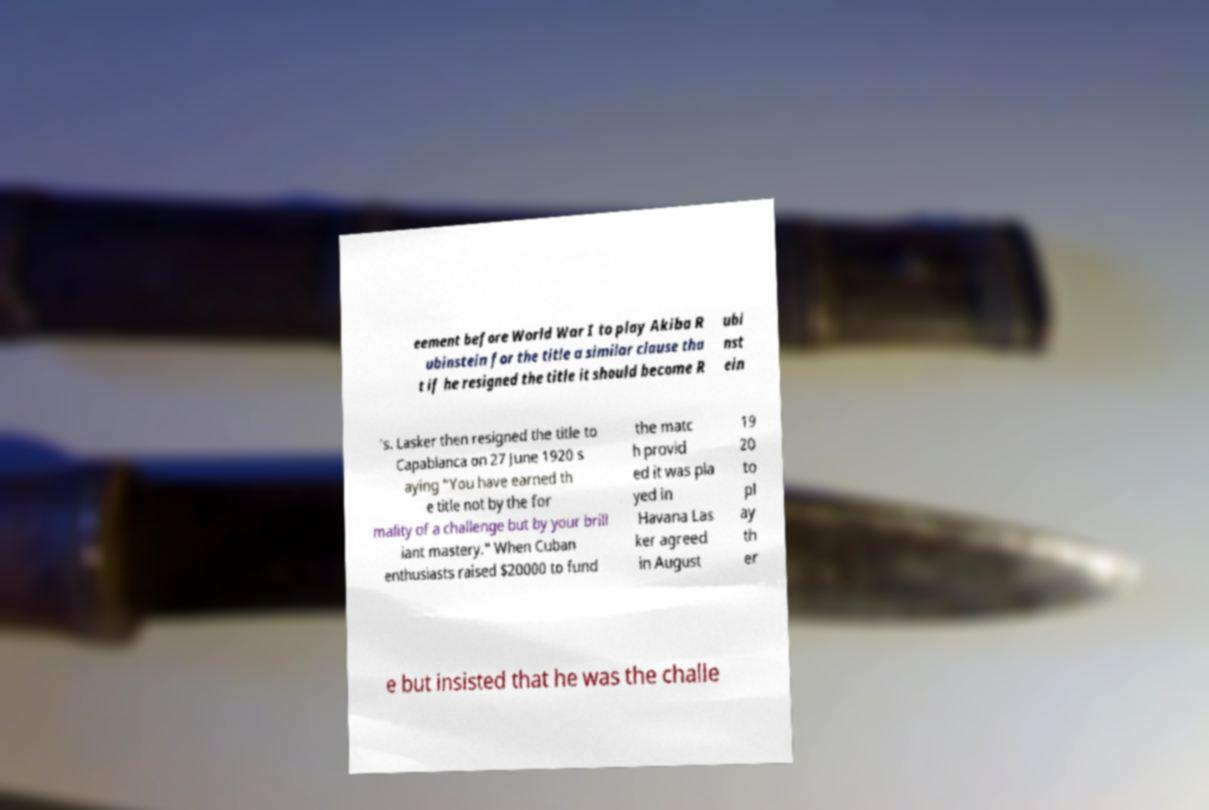Could you assist in decoding the text presented in this image and type it out clearly? eement before World War I to play Akiba R ubinstein for the title a similar clause tha t if he resigned the title it should become R ubi nst ein 's. Lasker then resigned the title to Capablanca on 27 June 1920 s aying "You have earned th e title not by the for mality of a challenge but by your brill iant mastery." When Cuban enthusiasts raised $20000 to fund the matc h provid ed it was pla yed in Havana Las ker agreed in August 19 20 to pl ay th er e but insisted that he was the challe 